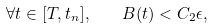Convert formula to latex. <formula><loc_0><loc_0><loc_500><loc_500>\forall t \in [ T , t _ { n } ] , \quad B ( t ) < C _ { 2 } \epsilon ,</formula> 